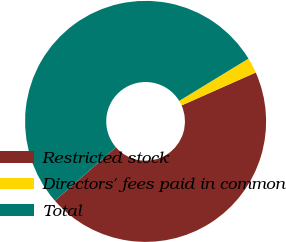<chart> <loc_0><loc_0><loc_500><loc_500><pie_chart><fcel>Restricted stock<fcel>Directors' fees paid in common<fcel>Total<nl><fcel>45.21%<fcel>2.07%<fcel>52.73%<nl></chart> 